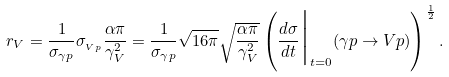Convert formula to latex. <formula><loc_0><loc_0><loc_500><loc_500>r _ { V } = \frac { 1 } { \sigma _ { \gamma p } } \sigma _ { _ { V p } } \frac { \alpha \pi } { \gamma _ { V } ^ { 2 } } = \frac { 1 } { \sigma _ { \gamma p } } \sqrt { 1 6 \pi } \sqrt { \frac { \alpha \pi } { \gamma _ { V } ^ { 2 } } } \left ( \frac { d \sigma } { d t } \Big | _ { t = 0 } \Big . ( \gamma p \rightarrow V p ) \right ) ^ { \frac { 1 } { 2 } } .</formula> 